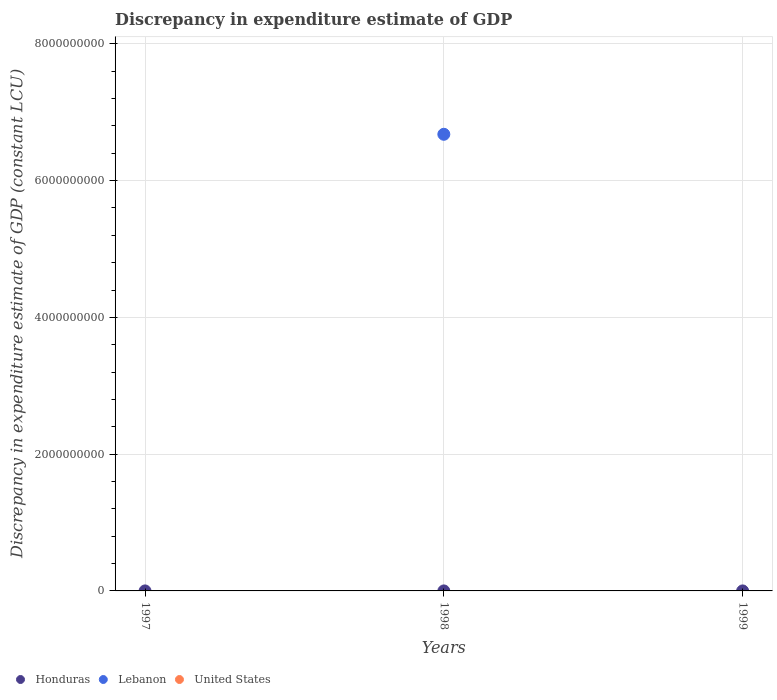How many different coloured dotlines are there?
Keep it short and to the point. 2. What is the discrepancy in expenditure estimate of GDP in Honduras in 1998?
Your answer should be compact. 9.23e+04. Across all years, what is the maximum discrepancy in expenditure estimate of GDP in Honduras?
Give a very brief answer. 9.27e+04. Across all years, what is the minimum discrepancy in expenditure estimate of GDP in Lebanon?
Offer a very short reply. 0. In which year was the discrepancy in expenditure estimate of GDP in Lebanon maximum?
Provide a short and direct response. 1998. What is the total discrepancy in expenditure estimate of GDP in Honduras in the graph?
Ensure brevity in your answer.  2.72e+05. What is the difference between the discrepancy in expenditure estimate of GDP in Honduras in 1997 and that in 1999?
Ensure brevity in your answer.  -5300. What is the difference between the discrepancy in expenditure estimate of GDP in Honduras in 1998 and the discrepancy in expenditure estimate of GDP in Lebanon in 1997?
Offer a very short reply. 9.23e+04. What is the average discrepancy in expenditure estimate of GDP in Lebanon per year?
Give a very brief answer. 2.23e+09. In how many years, is the discrepancy in expenditure estimate of GDP in Lebanon greater than 1200000000 LCU?
Offer a terse response. 1. What is the ratio of the discrepancy in expenditure estimate of GDP in Honduras in 1998 to that in 1999?
Provide a short and direct response. 1. What is the difference between the highest and the lowest discrepancy in expenditure estimate of GDP in Honduras?
Offer a very short reply. 5300. In how many years, is the discrepancy in expenditure estimate of GDP in Honduras greater than the average discrepancy in expenditure estimate of GDP in Honduras taken over all years?
Your response must be concise. 2. Is the sum of the discrepancy in expenditure estimate of GDP in Honduras in 1997 and 1998 greater than the maximum discrepancy in expenditure estimate of GDP in United States across all years?
Offer a very short reply. Yes. Is it the case that in every year, the sum of the discrepancy in expenditure estimate of GDP in United States and discrepancy in expenditure estimate of GDP in Lebanon  is greater than the discrepancy in expenditure estimate of GDP in Honduras?
Your answer should be very brief. No. Does the discrepancy in expenditure estimate of GDP in United States monotonically increase over the years?
Offer a terse response. Yes. Is the discrepancy in expenditure estimate of GDP in Honduras strictly greater than the discrepancy in expenditure estimate of GDP in Lebanon over the years?
Your answer should be compact. No. Is the discrepancy in expenditure estimate of GDP in Lebanon strictly less than the discrepancy in expenditure estimate of GDP in Honduras over the years?
Your response must be concise. No. How many dotlines are there?
Make the answer very short. 2. How many years are there in the graph?
Give a very brief answer. 3. What is the difference between two consecutive major ticks on the Y-axis?
Provide a succinct answer. 2.00e+09. How are the legend labels stacked?
Your answer should be compact. Horizontal. What is the title of the graph?
Keep it short and to the point. Discrepancy in expenditure estimate of GDP. What is the label or title of the X-axis?
Offer a terse response. Years. What is the label or title of the Y-axis?
Your answer should be compact. Discrepancy in expenditure estimate of GDP (constant LCU). What is the Discrepancy in expenditure estimate of GDP (constant LCU) of Honduras in 1997?
Offer a very short reply. 8.74e+04. What is the Discrepancy in expenditure estimate of GDP (constant LCU) of Lebanon in 1997?
Ensure brevity in your answer.  0. What is the Discrepancy in expenditure estimate of GDP (constant LCU) in Honduras in 1998?
Give a very brief answer. 9.23e+04. What is the Discrepancy in expenditure estimate of GDP (constant LCU) of Lebanon in 1998?
Provide a succinct answer. 6.68e+09. What is the Discrepancy in expenditure estimate of GDP (constant LCU) in Honduras in 1999?
Keep it short and to the point. 9.27e+04. What is the Discrepancy in expenditure estimate of GDP (constant LCU) in Lebanon in 1999?
Ensure brevity in your answer.  0. Across all years, what is the maximum Discrepancy in expenditure estimate of GDP (constant LCU) in Honduras?
Offer a very short reply. 9.27e+04. Across all years, what is the maximum Discrepancy in expenditure estimate of GDP (constant LCU) in Lebanon?
Your answer should be compact. 6.68e+09. Across all years, what is the minimum Discrepancy in expenditure estimate of GDP (constant LCU) in Honduras?
Your response must be concise. 8.74e+04. Across all years, what is the minimum Discrepancy in expenditure estimate of GDP (constant LCU) of Lebanon?
Ensure brevity in your answer.  0. What is the total Discrepancy in expenditure estimate of GDP (constant LCU) in Honduras in the graph?
Provide a succinct answer. 2.72e+05. What is the total Discrepancy in expenditure estimate of GDP (constant LCU) in Lebanon in the graph?
Provide a short and direct response. 6.68e+09. What is the total Discrepancy in expenditure estimate of GDP (constant LCU) in United States in the graph?
Offer a terse response. 0. What is the difference between the Discrepancy in expenditure estimate of GDP (constant LCU) of Honduras in 1997 and that in 1998?
Your answer should be compact. -4900. What is the difference between the Discrepancy in expenditure estimate of GDP (constant LCU) of Honduras in 1997 and that in 1999?
Offer a very short reply. -5300. What is the difference between the Discrepancy in expenditure estimate of GDP (constant LCU) in Honduras in 1998 and that in 1999?
Offer a very short reply. -400. What is the difference between the Discrepancy in expenditure estimate of GDP (constant LCU) in Honduras in 1997 and the Discrepancy in expenditure estimate of GDP (constant LCU) in Lebanon in 1998?
Offer a terse response. -6.68e+09. What is the average Discrepancy in expenditure estimate of GDP (constant LCU) in Honduras per year?
Provide a short and direct response. 9.08e+04. What is the average Discrepancy in expenditure estimate of GDP (constant LCU) in Lebanon per year?
Your response must be concise. 2.23e+09. What is the average Discrepancy in expenditure estimate of GDP (constant LCU) of United States per year?
Your response must be concise. 0. In the year 1998, what is the difference between the Discrepancy in expenditure estimate of GDP (constant LCU) of Honduras and Discrepancy in expenditure estimate of GDP (constant LCU) of Lebanon?
Give a very brief answer. -6.68e+09. What is the ratio of the Discrepancy in expenditure estimate of GDP (constant LCU) of Honduras in 1997 to that in 1998?
Your answer should be compact. 0.95. What is the ratio of the Discrepancy in expenditure estimate of GDP (constant LCU) of Honduras in 1997 to that in 1999?
Give a very brief answer. 0.94. What is the ratio of the Discrepancy in expenditure estimate of GDP (constant LCU) of Honduras in 1998 to that in 1999?
Your response must be concise. 1. What is the difference between the highest and the second highest Discrepancy in expenditure estimate of GDP (constant LCU) in Honduras?
Your response must be concise. 400. What is the difference between the highest and the lowest Discrepancy in expenditure estimate of GDP (constant LCU) in Honduras?
Your answer should be compact. 5300. What is the difference between the highest and the lowest Discrepancy in expenditure estimate of GDP (constant LCU) of Lebanon?
Keep it short and to the point. 6.68e+09. 